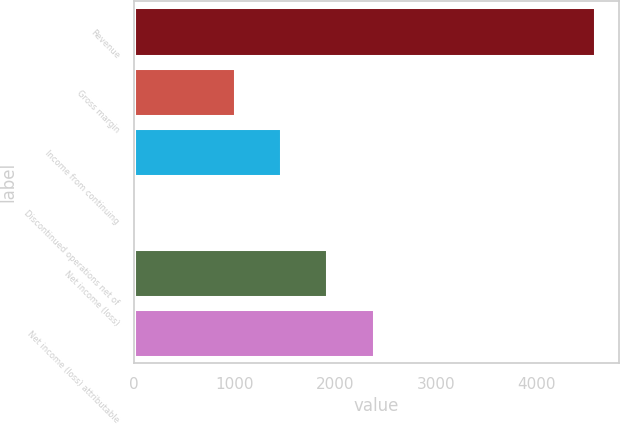Convert chart to OTSL. <chart><loc_0><loc_0><loc_500><loc_500><bar_chart><fcel>Revenue<fcel>Gross margin<fcel>Income from continuing<fcel>Discontinued operations net of<fcel>Net income (loss)<fcel>Net income (loss) attributable<nl><fcel>4587<fcel>1006<fcel>1464.5<fcel>2<fcel>1923<fcel>2381.5<nl></chart> 